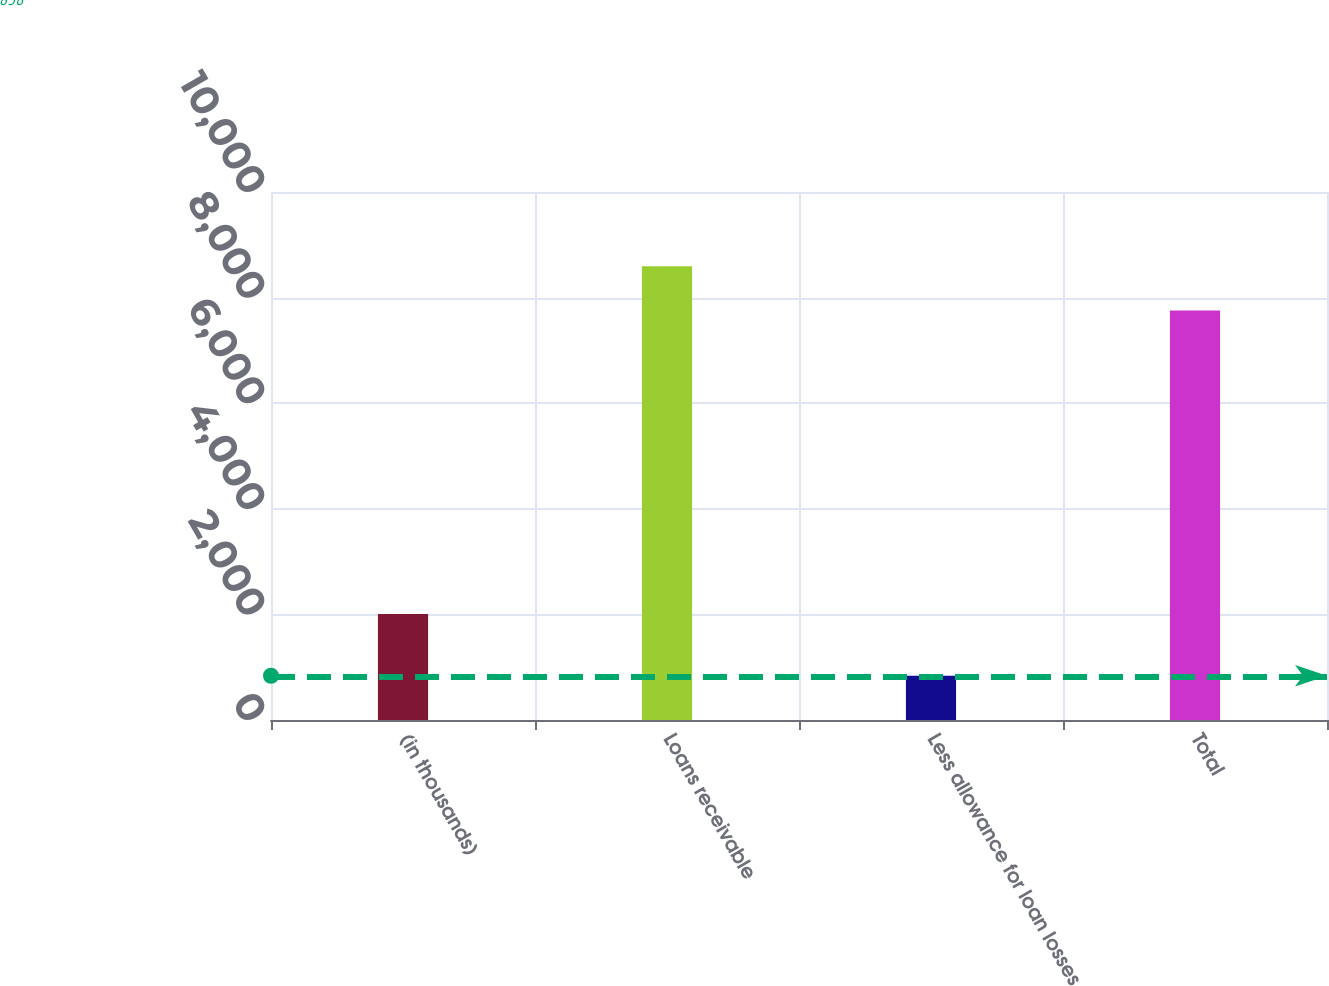Convert chart to OTSL. <chart><loc_0><loc_0><loc_500><loc_500><bar_chart><fcel>(in thousands)<fcel>Loans receivable<fcel>Less allowance for loan losses<fcel>Total<nl><fcel>2009<fcel>8593<fcel>838<fcel>7755<nl></chart> 